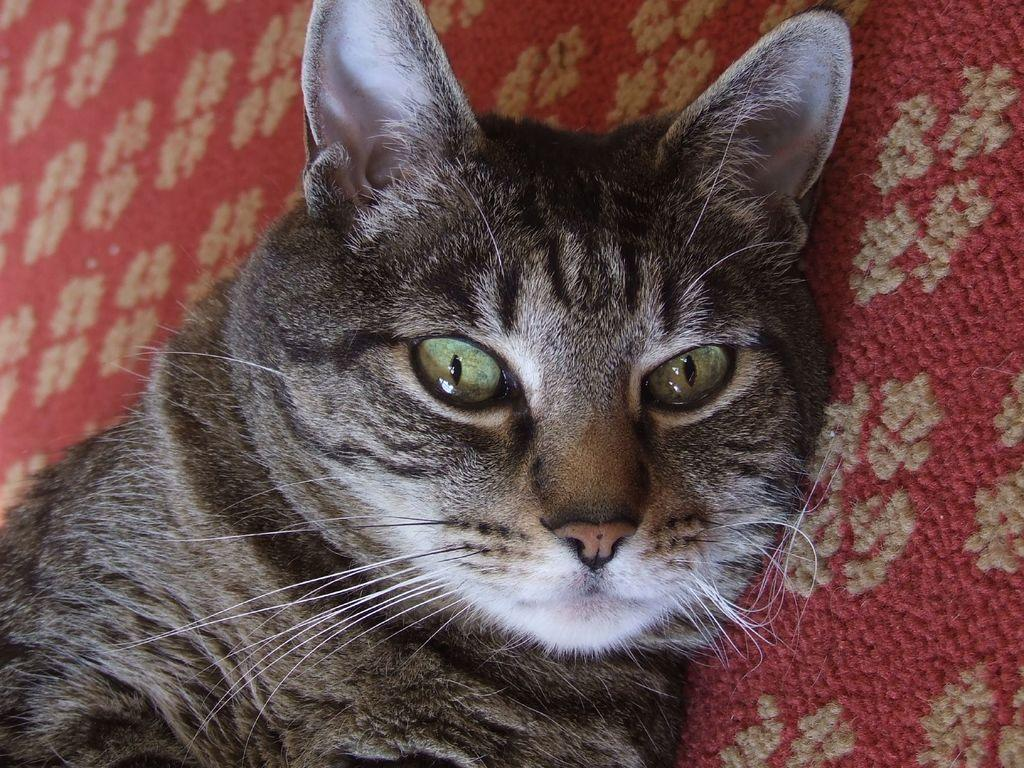What type of animal is in the image? There is a cat in the image. Where is the cat located? The cat is laying on a carpet. What type of plants are being discussed by the cat in the image? There is no discussion or plants present in the image; it only features a cat laying on a carpet. 